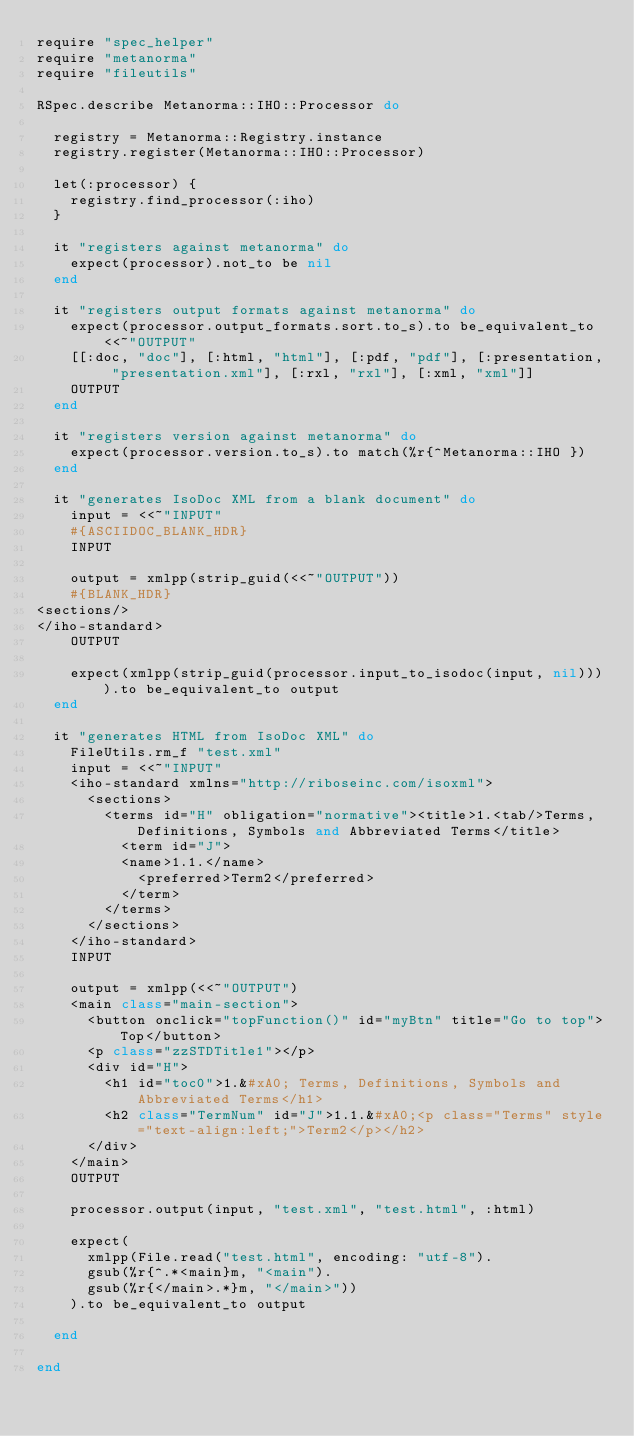Convert code to text. <code><loc_0><loc_0><loc_500><loc_500><_Ruby_>require "spec_helper"
require "metanorma"
require "fileutils"

RSpec.describe Metanorma::IHO::Processor do

  registry = Metanorma::Registry.instance
  registry.register(Metanorma::IHO::Processor)

  let(:processor) {
    registry.find_processor(:iho)
  }

  it "registers against metanorma" do
    expect(processor).not_to be nil
  end

  it "registers output formats against metanorma" do
    expect(processor.output_formats.sort.to_s).to be_equivalent_to <<~"OUTPUT"
    [[:doc, "doc"], [:html, "html"], [:pdf, "pdf"], [:presentation, "presentation.xml"], [:rxl, "rxl"], [:xml, "xml"]]
    OUTPUT
  end

  it "registers version against metanorma" do
    expect(processor.version.to_s).to match(%r{^Metanorma::IHO })
  end

  it "generates IsoDoc XML from a blank document" do
    input = <<~"INPUT"
    #{ASCIIDOC_BLANK_HDR}
    INPUT

    output = xmlpp(strip_guid(<<~"OUTPUT"))
    #{BLANK_HDR}
<sections/>
</iho-standard>
    OUTPUT

    expect(xmlpp(strip_guid(processor.input_to_isodoc(input, nil)))).to be_equivalent_to output
  end

  it "generates HTML from IsoDoc XML" do
    FileUtils.rm_f "test.xml"
    input = <<~"INPUT"
    <iho-standard xmlns="http://riboseinc.com/isoxml">
      <sections>
        <terms id="H" obligation="normative"><title>1.<tab/>Terms, Definitions, Symbols and Abbreviated Terms</title>
          <term id="J">
          <name>1.1.</name>
            <preferred>Term2</preferred>
          </term>
        </terms>
      </sections>
    </iho-standard>
    INPUT

    output = xmlpp(<<~"OUTPUT")
    <main class="main-section">
      <button onclick="topFunction()" id="myBtn" title="Go to top">Top</button>
      <p class="zzSTDTitle1"></p>
      <div id="H">
        <h1 id="toc0">1.&#xA0; Terms, Definitions, Symbols and Abbreviated Terms</h1>
        <h2 class="TermNum" id="J">1.1.&#xA0;<p class="Terms" style="text-align:left;">Term2</p></h2>
      </div>
    </main>
    OUTPUT

    processor.output(input, "test.xml", "test.html", :html)

    expect(
      xmlpp(File.read("test.html", encoding: "utf-8").
      gsub(%r{^.*<main}m, "<main").
      gsub(%r{</main>.*}m, "</main>"))
    ).to be_equivalent_to output

  end

end
</code> 